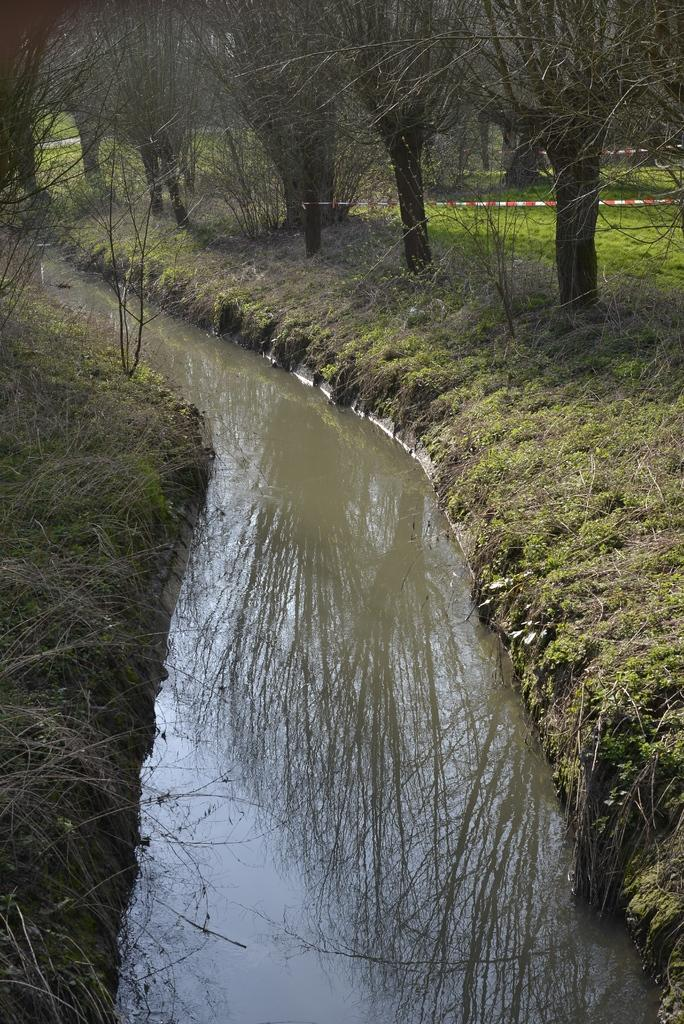What is the main feature in the image? There is a ditch in the image. What type of vegetation is present around the ditch? Grass is present around the ditch. Are there any other natural elements visible in the image? Trees are visible around the ditch. What type of poison is being used to treat the trees in the image? There is no indication of any poison being used in the image; the trees are simply visible around the ditch. 